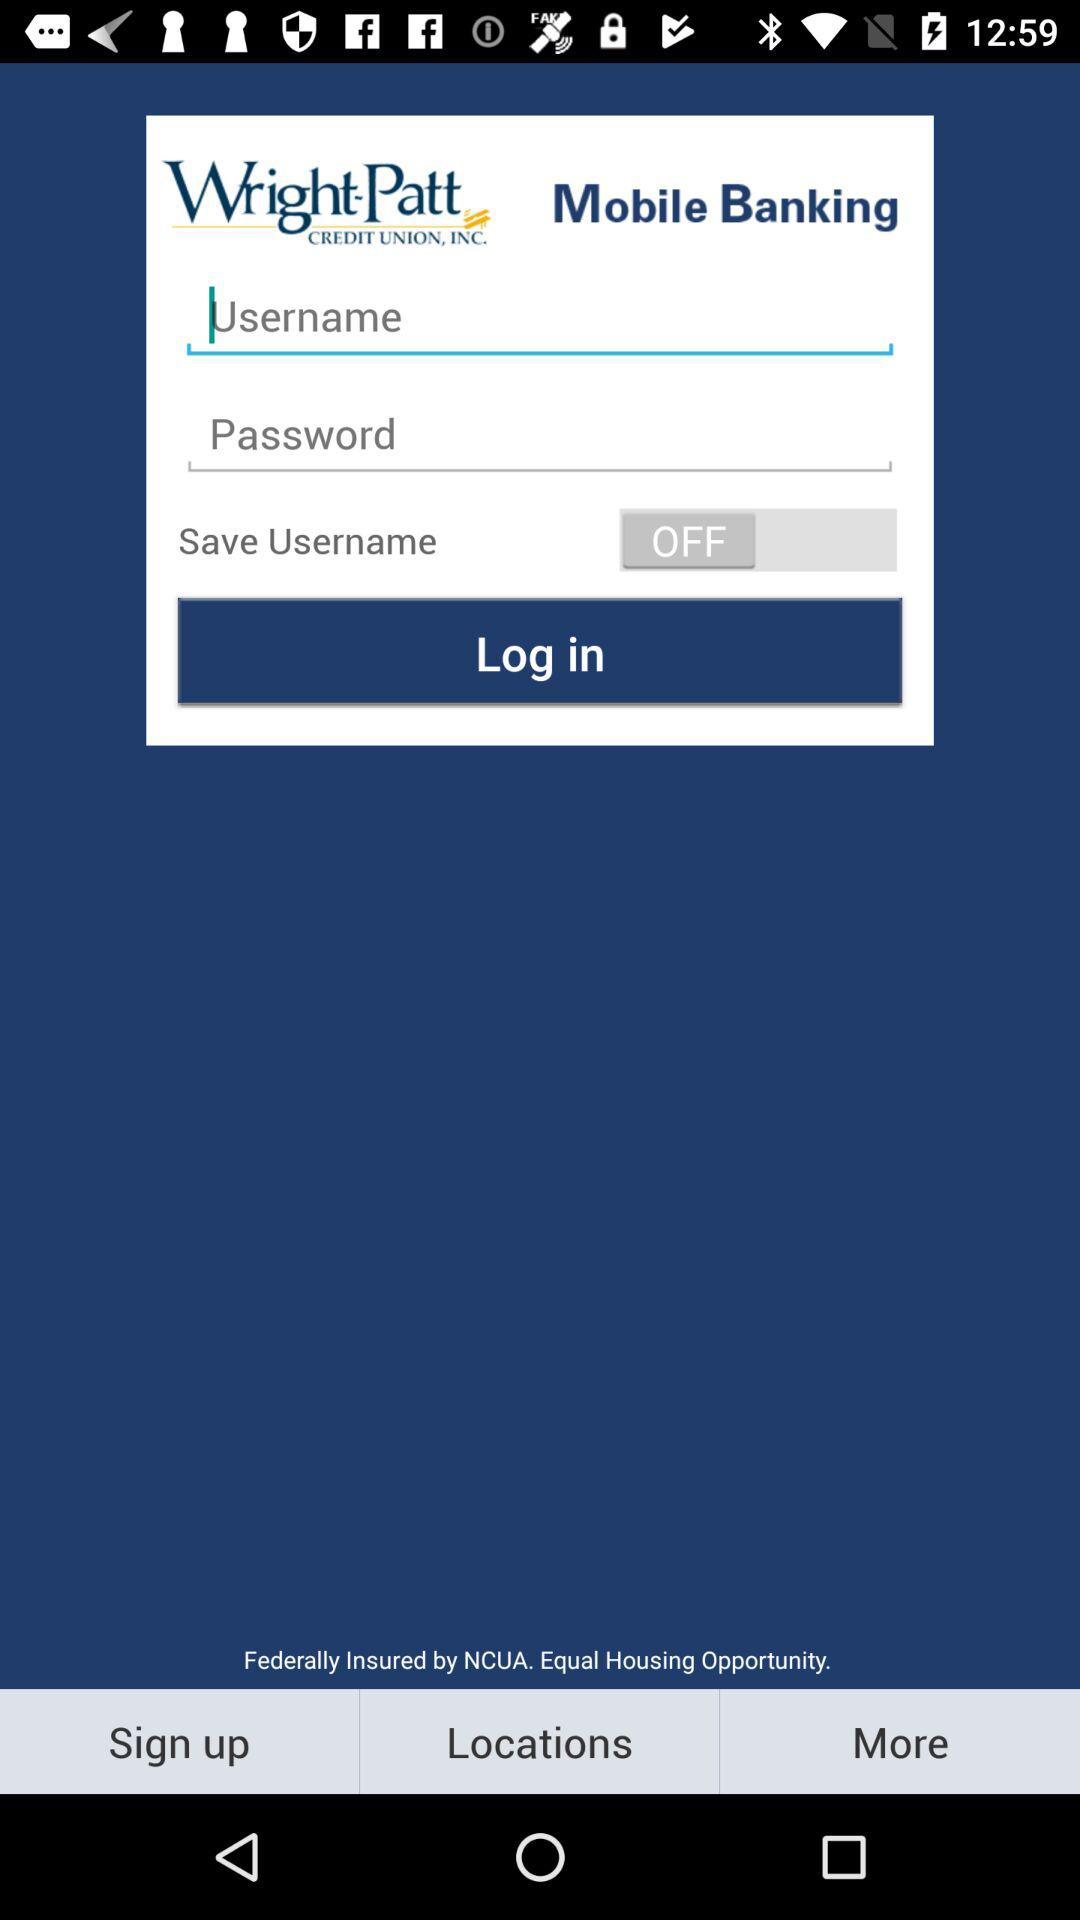What is the name of the application? The name of the application is "Wright-Patt CREDIT UNION, INC. Mobile Banking". 